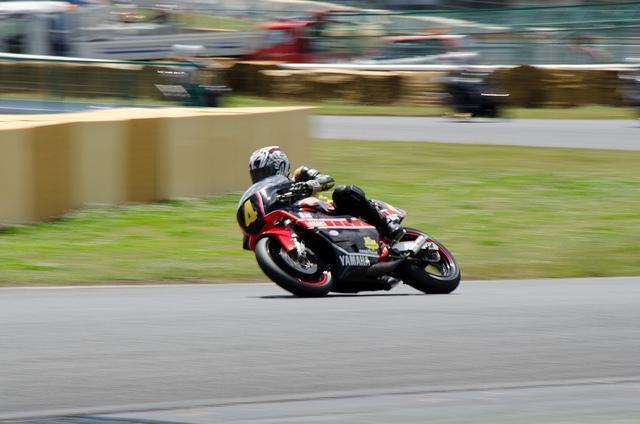How many motorcycles are there?
Give a very brief answer. 1. 